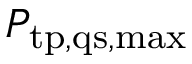<formula> <loc_0><loc_0><loc_500><loc_500>P _ { t p , q s , \max }</formula> 